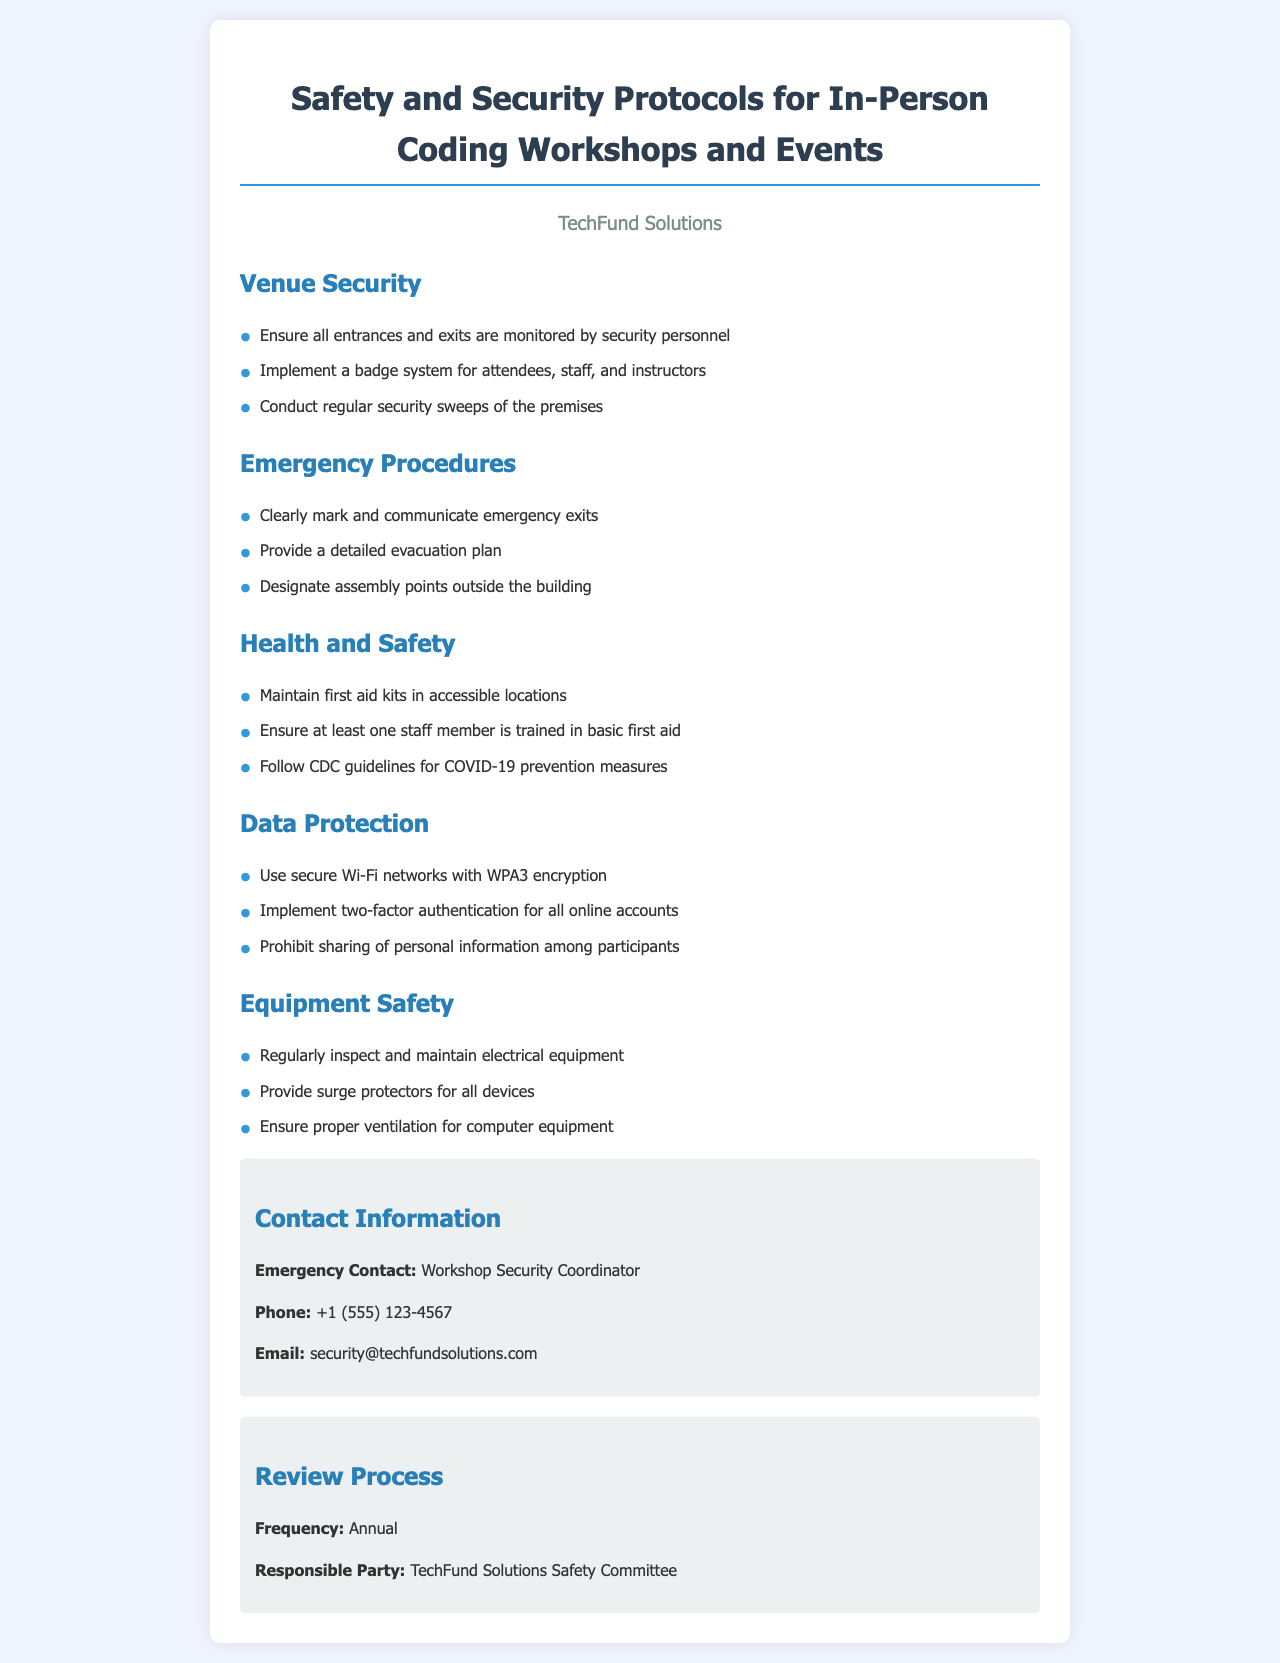What are the emergency contact details? The document provides emergency contact information for the Workshop Security Coordinator, including phone and email.
Answer: Workshop Security Coordinator, +1 (555) 123-4567, security@techfundsolutions.com What is the frequency of the review process? The document states how often the safety protocols are reviewed, which is specifically mentioned under the Review Process section.
Answer: Annual Who is responsible for the safety review? The document indicates the party responsible for the safety review, which is specified in the Review Process section.
Answer: TechFund Solutions Safety Committee What kind of network encryption should be used? The document specifies the type of encryption to be implemented for secure Wi-Fi networks in the Data Protection section.
Answer: WPA3 How many items are there in the Health and Safety list? The Health and Safety section contains specific items that detail health-related protocols; counting these gives the total.
Answer: 3 What are the designated assembly points for emergencies? The document includes details about emergency procedures, specifically mentioning assembly points.
Answer: Outside the building What should be ensured regarding first aid during workshops? The Health and Safety section states the requirement concerning first aid training among staff during workshops.
Answer: One staff member trained in basic first aid What type of authentication is required for online accounts? The Data Protection section indicates the security measure required for online accounts.
Answer: Two-factor authentication 